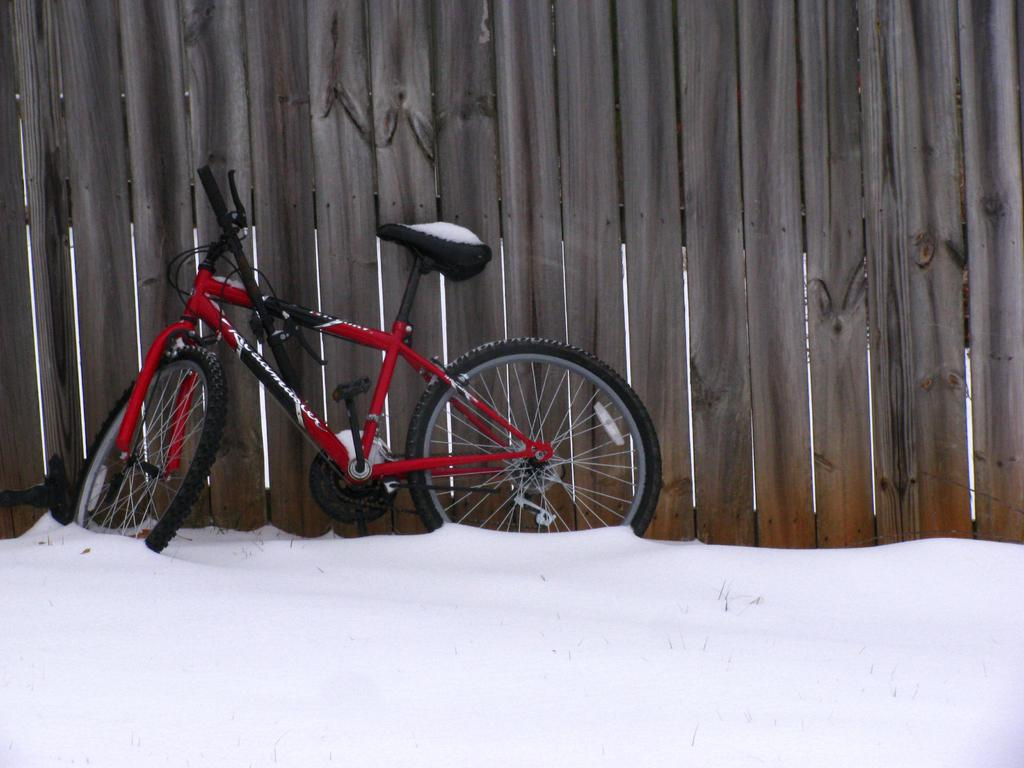What is the main object in the image? There is a cycle in the image. How is the cycle positioned in relation to the wooden fence? The cycle is leaning into a wooden fence. What type of terrain is visible in the image? The surface of the snow is visible in the image. What type of love can be seen expressed between the cycle and the wooden fence in the image? There is no expression of love between the cycle and the wooden fence in the image; it is simply a cycle leaning against a fence. 